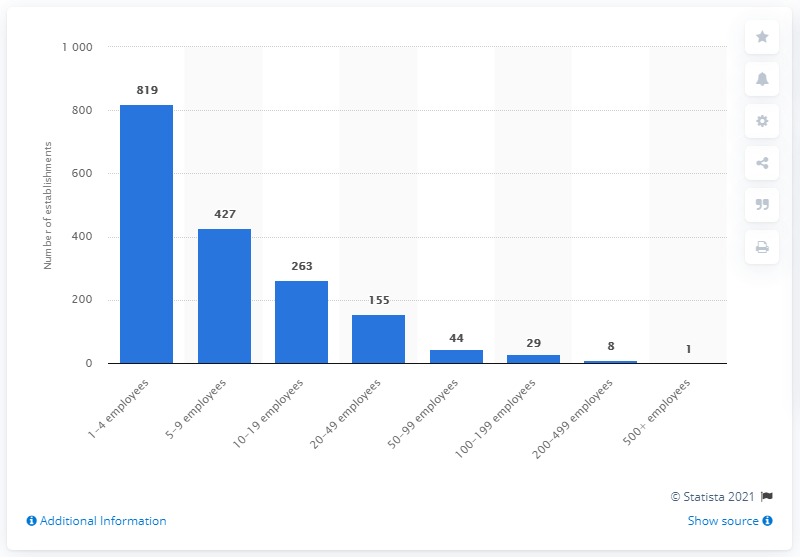Mention a couple of crucial points in this snapshot. At the end of 2020, there were 819 micro wood kitchen cabinet and countertop manufacturing establishments in Canada. 